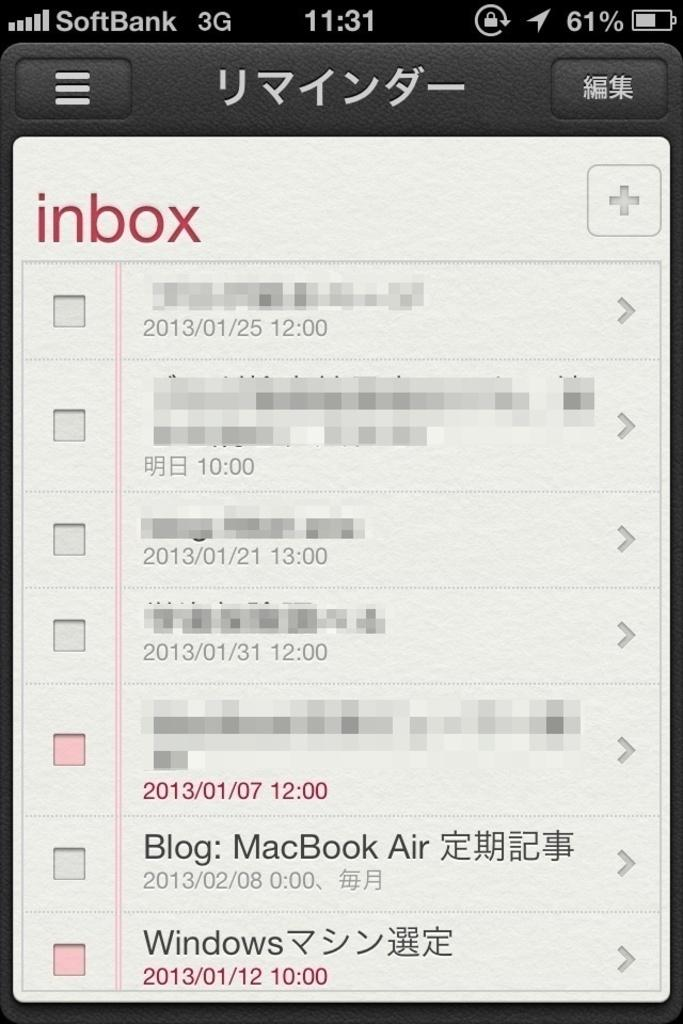<image>
Share a concise interpretation of the image provided. The image includes a message about a MacBook Air. 